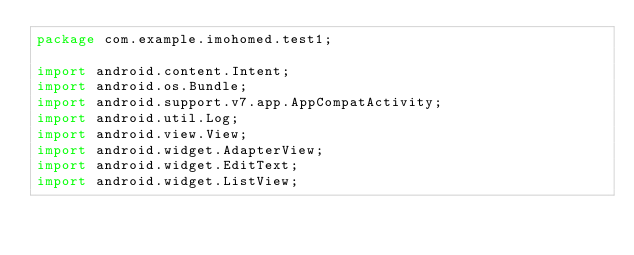<code> <loc_0><loc_0><loc_500><loc_500><_Java_>package com.example.imohomed.test1;

import android.content.Intent;
import android.os.Bundle;
import android.support.v7.app.AppCompatActivity;
import android.util.Log;
import android.view.View;
import android.widget.AdapterView;
import android.widget.EditText;
import android.widget.ListView;</code> 